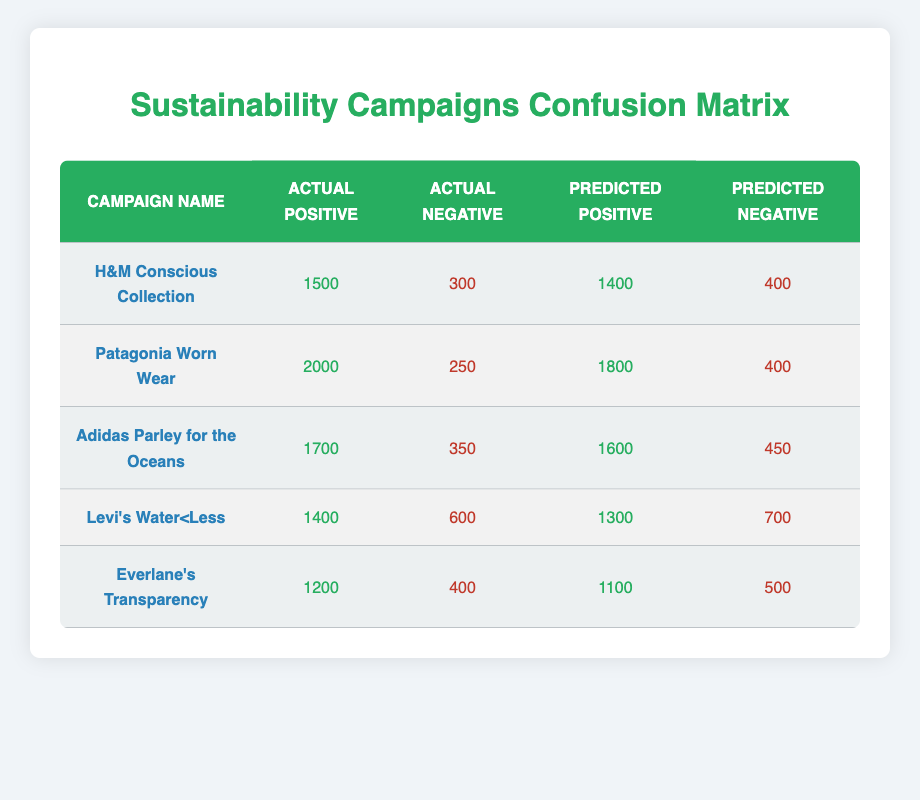What is the actual positive count for the H&M Conscious Collection campaign? The actual positive count for the H&M Conscious Collection campaign is listed in the table, which shows 1500.
Answer: 1500 How many campaigns have an actual negative count greater than 300? By reviewing the "Actual Negative" column, the campaigns with counts greater than 300 are Levi's Water<Less (600), Adidas Parley for the Oceans (350), and Patagonia Worn Wear (400). That gives a total of 3 campaigns.
Answer: 3 What is the predicted negative count for the Adidas Parley for the Oceans campaign? The table provides the predicted negative count for each campaign. For the Adidas Parley for the Oceans campaign, the count is 450.
Answer: 450 Which campaign had the highest number of actual positives? To find the campaign with the highest actual positive, we can read the "Actual Positive" column, where Patagonia Worn Wear shows the highest value of 2000.
Answer: Patagonia Worn Wear What is the difference between the predicted positives of H&M Conscious Collection and Everlane's Transparency? We take the predicted positive counts for both campaigns from the table: H&M Conscious Collection shows 1400 and Everlane's Transparency shows 1100. The difference is calculated as 1400 - 1100 = 300.
Answer: 300 Do any campaigns have the same number of actual positives and actual negatives? A close observation of the table indicates that no campaigns listed have equal actual positives and actual negatives counts.
Answer: No Which campaign has a lower predicted positive count than actual positive count by more than 100? Comparing the "Predicted Positive" column with the "Actual Positive" column, both Levi's Water<Less (difference of 100) and Everlane's Transparency (difference of 100) do not qualify since the differences are exactly equal; however, H&M Conscious Collection (100) and Adidas Parley for the Oceans (100) also do not meet this criterion. Thus, no campaigns fall into this category.
Answer: None How many campaigns have predicted positives less than 1500? Looking at the "Predicted Positive" column, the campaigns with predicted positives less than 1500 are Levi's Water<Less (1300) and Everlane’s Transparency (1100), totaling 2 campaigns.
Answer: 2 What is the ratio of actual positives to actual negatives for Patagonia Worn Wear? The actual positives for Patagonia Worn Wear is 2000 and the actual negatives is 250. The ratio is 2000:250 which simplifies to 8:1.
Answer: 8:1 